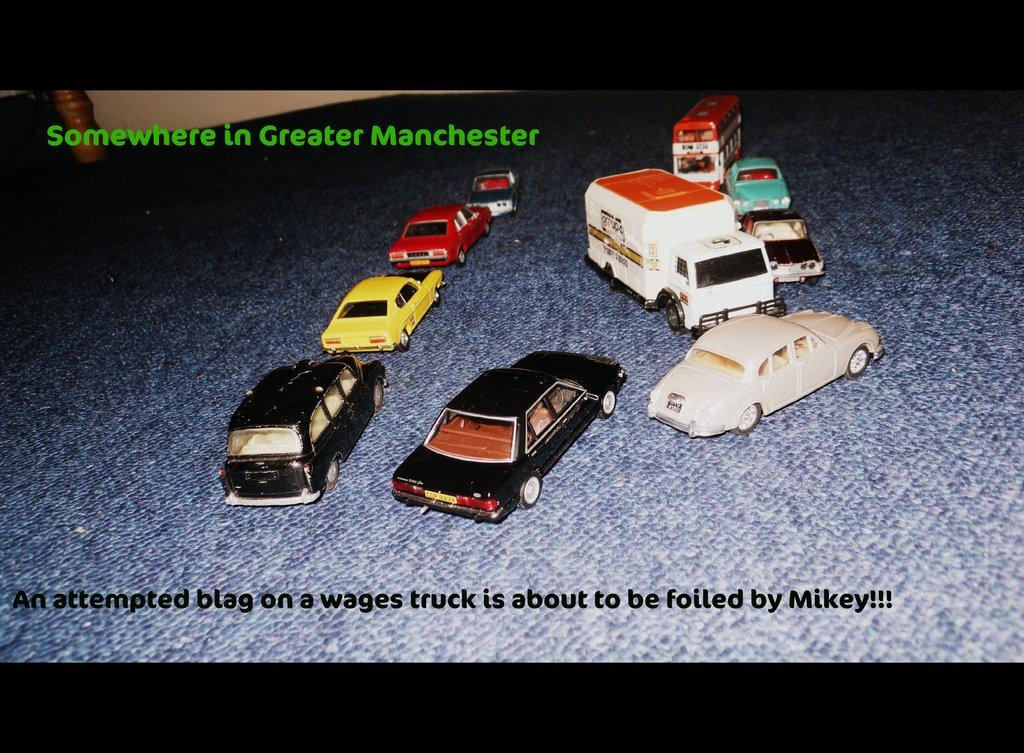What type of objects are present in the image? There are toy vehicles in the image. Where are the toy vehicles located? The toy vehicles are on an object. Can you describe any imperfections or marks on the image? There are watermarks on the image. What type of harmony can be heard in the background of the image? There is no audible harmony in the image, as it is a still image of toy vehicles. 